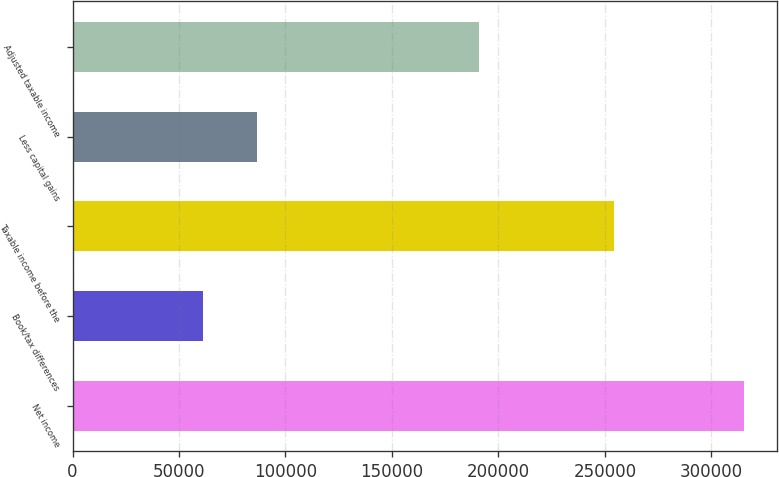<chart> <loc_0><loc_0><loc_500><loc_500><bar_chart><fcel>Net income<fcel>Book/tax differences<fcel>Taxable income before the<fcel>Less capital gains<fcel>Adjusted taxable income<nl><fcel>315278<fcel>61138<fcel>254140<fcel>86552<fcel>190944<nl></chart> 